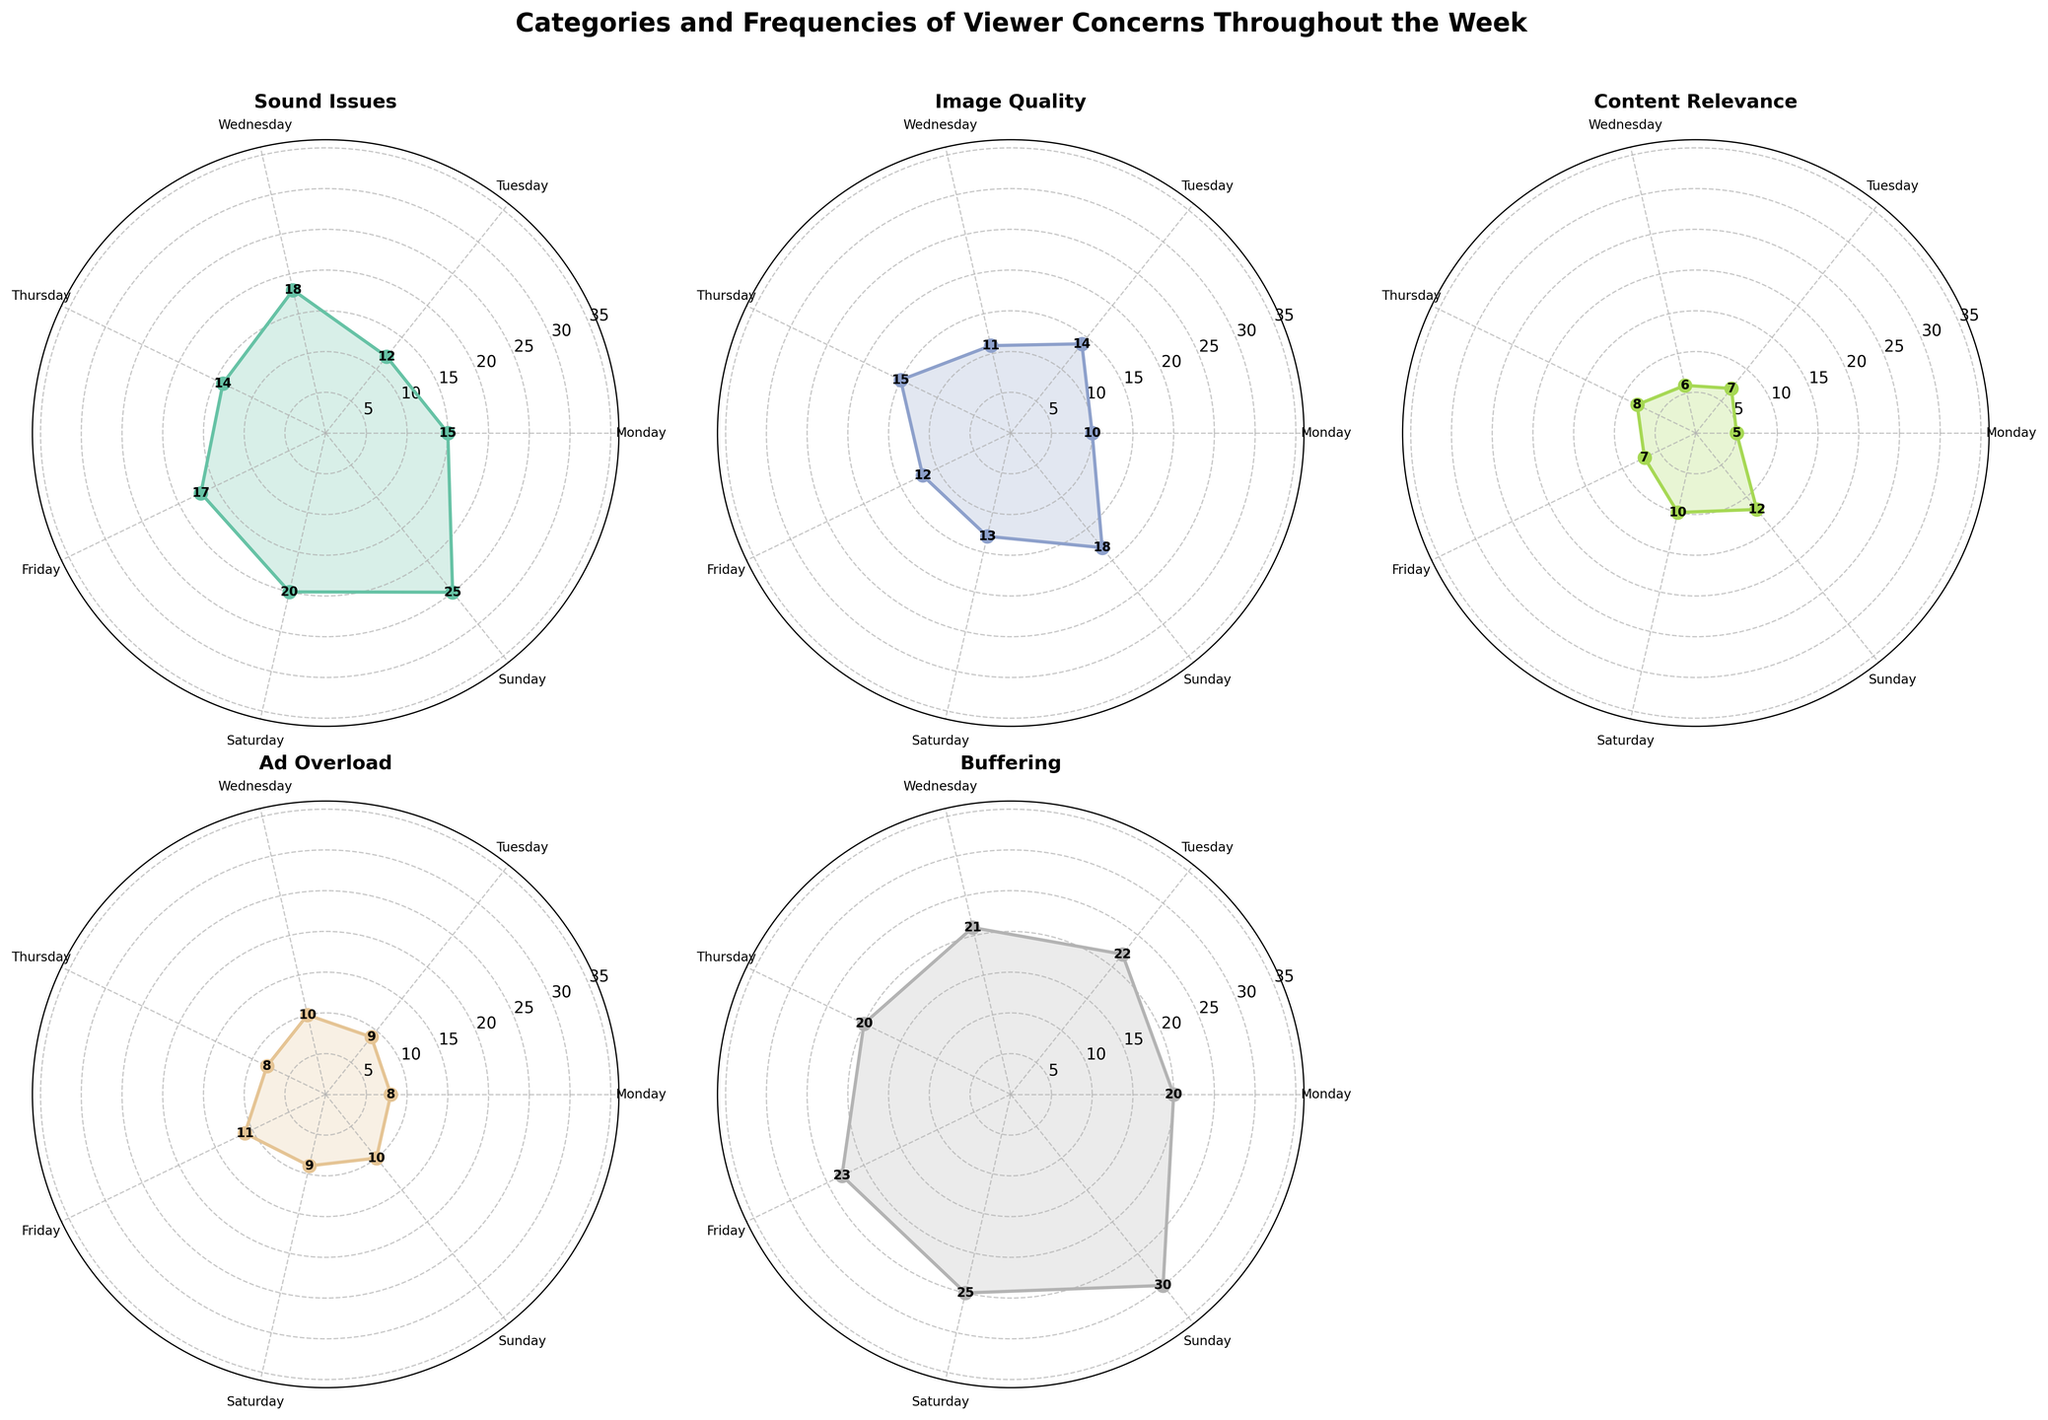What day has the highest frequency for Sound Issues? By looking at the plot for Sound Issues, the day where the line reaches the highest point is Sunday.
Answer: Sunday What's the average frequency of Content Relevance concerns throughout the week? The frequencies for Content Relevance are [5, 7, 6, 8, 7, 10, 12]. Summing these gives 55. Dividing by the number of days (7) gives an average of 55/7 = 7.86.
Answer: 7.86 Which category has the lowest maximum frequency? Comparing the peaks of each category, Image Quality has its highest peak at 18 on Sunday, which is lower than the maximum peaks for other categories.
Answer: Image Quality How much higher is the highest Buffering frequency compared to the lowest Buffering frequency? The highest Buffering frequency is 30 (Sunday) and the lowest is 20 (Monday and Thursday). The difference is 30 - 20 = 10.
Answer: 10 What is the main title of the plot? The title is written at the top of the figure.
Answer: Categories and Frequencies of Viewer Concerns Throughout the Week On which two consecutive days did Buffering issues stay the same? Looking at the Buffering subplot, Buffering issues were the same on Monday and Thursday, both with a frequency of 20.
Answer: Monday and Thursday How does the frequency of Content Relevance concerns on Wednesday compare to Tuesday? The frequency on Wednesday is 6 and on Tuesday is 7. So, Wednesday's value is 1 less than Tuesday's.
Answer: 1 less What are the color variations used to represent different categories? Each category is represented by different colors from the color palette used, but exact color details aren’t specified. However, colors are visually distinguishable.
Answer: Various Which day shows the greatest variation in frequencies across categories? By examining the spread of points for each category subplot, Sunday shows the largest spread with values ranging from 10 (Ad Overload) to 30 (Buffering), which is the greatest variation.
Answer: Sunday 